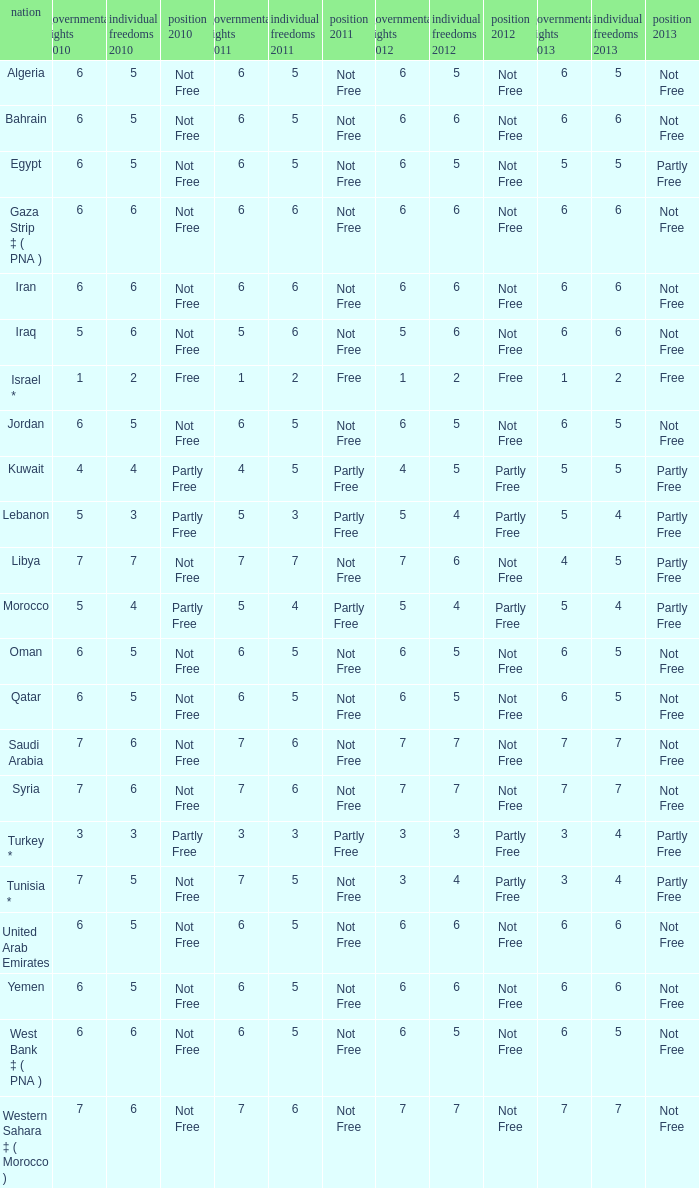What is the average 2012 civil liberties value associated with a 2011 status of not free, political rights 2012 over 6, and political rights 2011 over 7? None. 